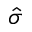Convert formula to latex. <formula><loc_0><loc_0><loc_500><loc_500>\hat { \sigma }</formula> 